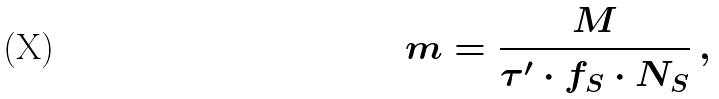Convert formula to latex. <formula><loc_0><loc_0><loc_500><loc_500>m = \frac { M } { \tau ^ { \prime } \cdot f _ { S } \cdot N _ { S } } \, ,</formula> 